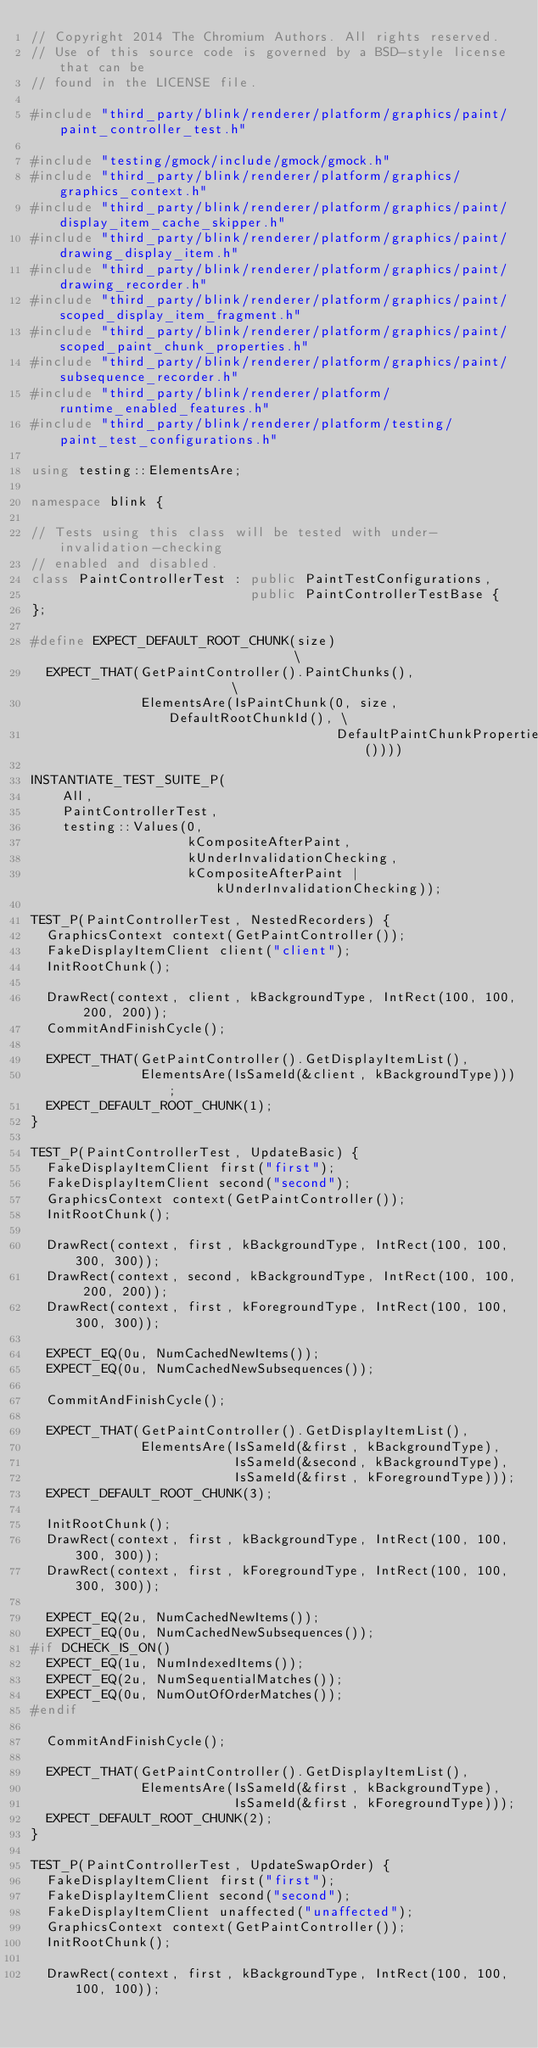<code> <loc_0><loc_0><loc_500><loc_500><_C++_>// Copyright 2014 The Chromium Authors. All rights reserved.
// Use of this source code is governed by a BSD-style license that can be
// found in the LICENSE file.

#include "third_party/blink/renderer/platform/graphics/paint/paint_controller_test.h"

#include "testing/gmock/include/gmock/gmock.h"
#include "third_party/blink/renderer/platform/graphics/graphics_context.h"
#include "third_party/blink/renderer/platform/graphics/paint/display_item_cache_skipper.h"
#include "third_party/blink/renderer/platform/graphics/paint/drawing_display_item.h"
#include "third_party/blink/renderer/platform/graphics/paint/drawing_recorder.h"
#include "third_party/blink/renderer/platform/graphics/paint/scoped_display_item_fragment.h"
#include "third_party/blink/renderer/platform/graphics/paint/scoped_paint_chunk_properties.h"
#include "third_party/blink/renderer/platform/graphics/paint/subsequence_recorder.h"
#include "third_party/blink/renderer/platform/runtime_enabled_features.h"
#include "third_party/blink/renderer/platform/testing/paint_test_configurations.h"

using testing::ElementsAre;

namespace blink {

// Tests using this class will be tested with under-invalidation-checking
// enabled and disabled.
class PaintControllerTest : public PaintTestConfigurations,
                            public PaintControllerTestBase {
};

#define EXPECT_DEFAULT_ROOT_CHUNK(size)                               \
  EXPECT_THAT(GetPaintController().PaintChunks(),                     \
              ElementsAre(IsPaintChunk(0, size, DefaultRootChunkId(), \
                                       DefaultPaintChunkProperties())))

INSTANTIATE_TEST_SUITE_P(
    All,
    PaintControllerTest,
    testing::Values(0,
                    kCompositeAfterPaint,
                    kUnderInvalidationChecking,
                    kCompositeAfterPaint | kUnderInvalidationChecking));

TEST_P(PaintControllerTest, NestedRecorders) {
  GraphicsContext context(GetPaintController());
  FakeDisplayItemClient client("client");
  InitRootChunk();

  DrawRect(context, client, kBackgroundType, IntRect(100, 100, 200, 200));
  CommitAndFinishCycle();

  EXPECT_THAT(GetPaintController().GetDisplayItemList(),
              ElementsAre(IsSameId(&client, kBackgroundType)));
  EXPECT_DEFAULT_ROOT_CHUNK(1);
}

TEST_P(PaintControllerTest, UpdateBasic) {
  FakeDisplayItemClient first("first");
  FakeDisplayItemClient second("second");
  GraphicsContext context(GetPaintController());
  InitRootChunk();

  DrawRect(context, first, kBackgroundType, IntRect(100, 100, 300, 300));
  DrawRect(context, second, kBackgroundType, IntRect(100, 100, 200, 200));
  DrawRect(context, first, kForegroundType, IntRect(100, 100, 300, 300));

  EXPECT_EQ(0u, NumCachedNewItems());
  EXPECT_EQ(0u, NumCachedNewSubsequences());

  CommitAndFinishCycle();

  EXPECT_THAT(GetPaintController().GetDisplayItemList(),
              ElementsAre(IsSameId(&first, kBackgroundType),
                          IsSameId(&second, kBackgroundType),
                          IsSameId(&first, kForegroundType)));
  EXPECT_DEFAULT_ROOT_CHUNK(3);

  InitRootChunk();
  DrawRect(context, first, kBackgroundType, IntRect(100, 100, 300, 300));
  DrawRect(context, first, kForegroundType, IntRect(100, 100, 300, 300));

  EXPECT_EQ(2u, NumCachedNewItems());
  EXPECT_EQ(0u, NumCachedNewSubsequences());
#if DCHECK_IS_ON()
  EXPECT_EQ(1u, NumIndexedItems());
  EXPECT_EQ(2u, NumSequentialMatches());
  EXPECT_EQ(0u, NumOutOfOrderMatches());
#endif

  CommitAndFinishCycle();

  EXPECT_THAT(GetPaintController().GetDisplayItemList(),
              ElementsAre(IsSameId(&first, kBackgroundType),
                          IsSameId(&first, kForegroundType)));
  EXPECT_DEFAULT_ROOT_CHUNK(2);
}

TEST_P(PaintControllerTest, UpdateSwapOrder) {
  FakeDisplayItemClient first("first");
  FakeDisplayItemClient second("second");
  FakeDisplayItemClient unaffected("unaffected");
  GraphicsContext context(GetPaintController());
  InitRootChunk();

  DrawRect(context, first, kBackgroundType, IntRect(100, 100, 100, 100));</code> 